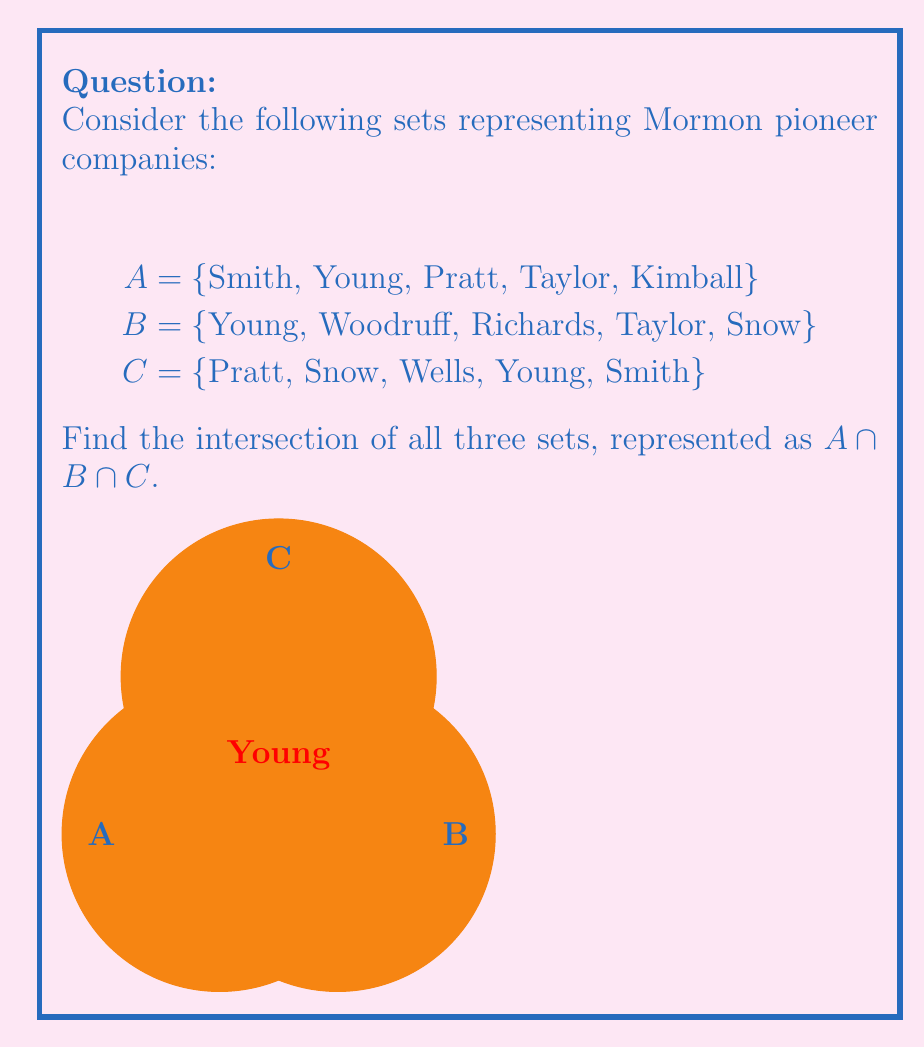Provide a solution to this math problem. To find the intersection of sets A, B, and C, we need to identify the elements that are common to all three sets. Let's approach this step-by-step:

1) First, let's list out the elements of each set:
   A = {Smith, Young, Pratt, Taylor, Kimball}
   B = {Young, Woodruff, Richards, Taylor, Snow}
   C = {Pratt, Snow, Wells, Young, Smith}

2) Now, we need to find elements that appear in all three sets. We can do this by checking each element:

   - Smith: in A and C, but not in B
   - Young: in A, B, and C
   - Pratt: in A and C, but not in B
   - Taylor: in A and B, but not in C
   - Kimball: only in A
   - Woodruff: only in B
   - Richards: only in B
   - Snow: in B and C, but not in A
   - Wells: only in C

3) From this analysis, we can see that only "Young" appears in all three sets.

4) Therefore, the intersection of A, B, and C is the set containing only Young.

5) In set notation, we write this as:

   $A \cap B \cap C = \{Young\}$

This result is represented in the Venn diagram by the central region where all three circles overlap.
Answer: $\{Young\}$ 